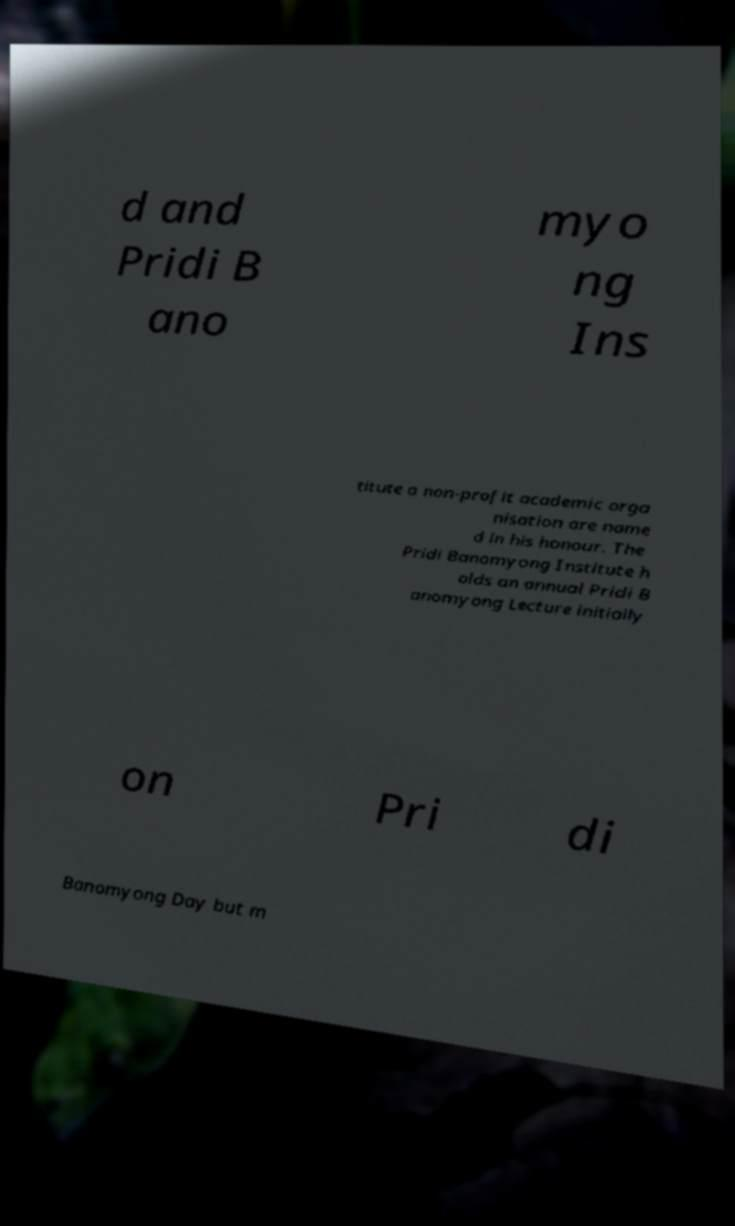Please identify and transcribe the text found in this image. d and Pridi B ano myo ng Ins titute a non-profit academic orga nisation are name d in his honour. The Pridi Banomyong Institute h olds an annual Pridi B anomyong Lecture initially on Pri di Banomyong Day but m 